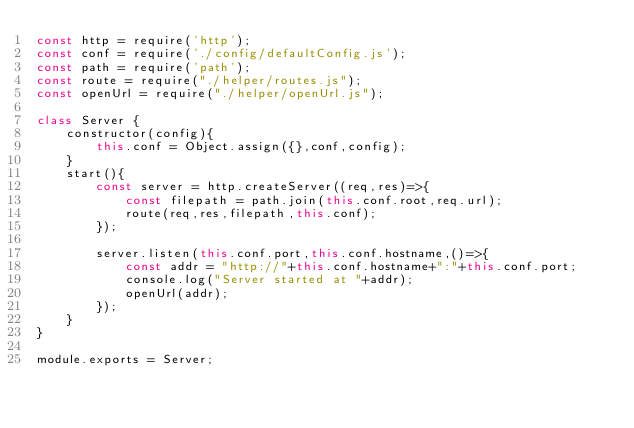Convert code to text. <code><loc_0><loc_0><loc_500><loc_500><_JavaScript_>const http = require('http');
const conf = require('./config/defaultConfig.js');
const path = require('path');
const route = require("./helper/routes.js");
const openUrl = require("./helper/openUrl.js");

class Server {
	constructor(config){
		this.conf = Object.assign({},conf,config);
	}
	start(){
		const server = http.createServer((req,res)=>{
			const filepath = path.join(this.conf.root,req.url);
    		route(req,res,filepath,this.conf);
		});

		server.listen(this.conf.port,this.conf.hostname,()=>{
			const addr = "http://"+this.conf.hostname+":"+this.conf.port;
			console.log("Server started at "+addr);
			openUrl(addr);
		});
	}
}

module.exports = Server;
</code> 